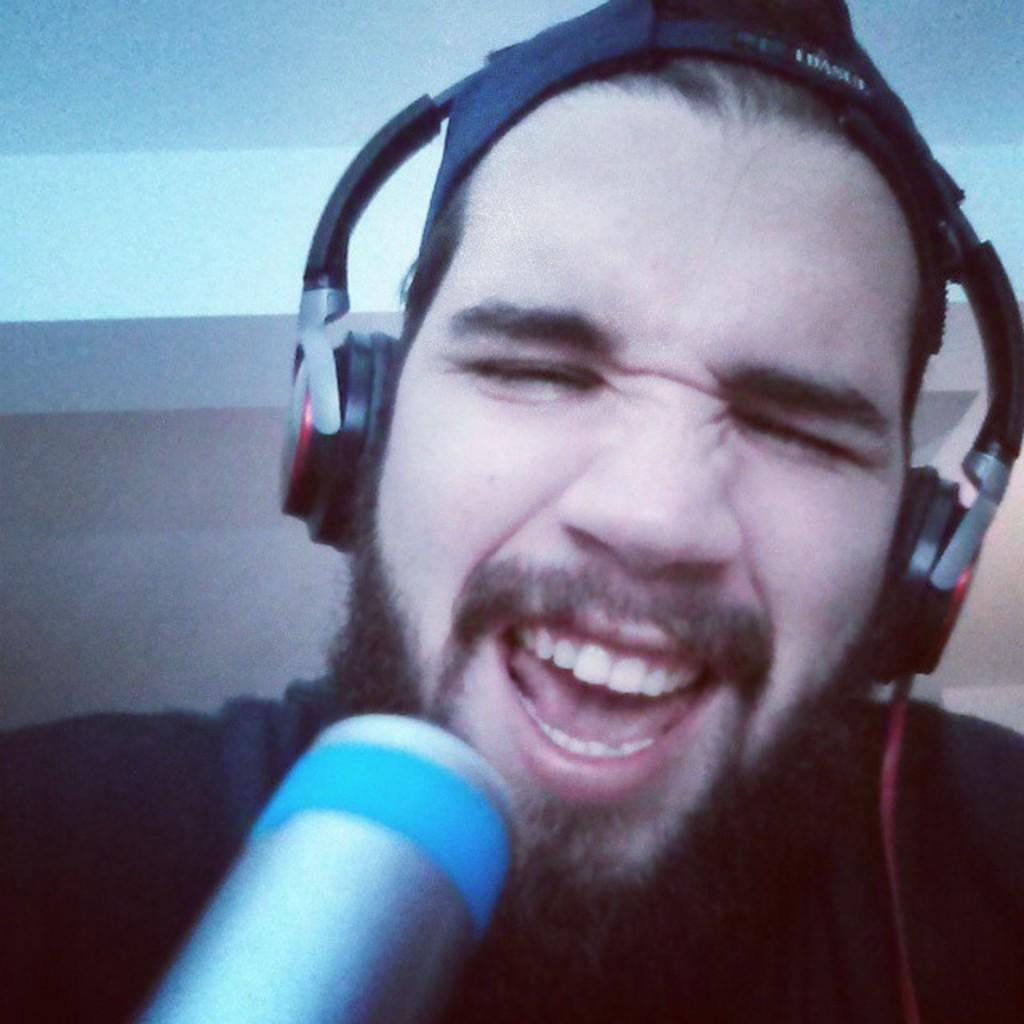Who or what is present in the image? There is a person in the image. What is the person wearing? The person is wearing a headset. Can you describe the object at the bottom of the image? Unfortunately, the facts provided do not give enough information about the object at the bottom of the image. What can be seen in the background of the image? The background of the image is visible. What type of question is being asked by the fire in the image? There is no fire present in the image, so it is not possible to answer that question. 